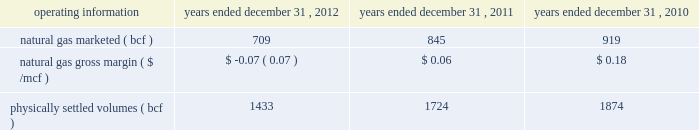Costs .
Our 2012 results were lower than 2011 when we realized $ 53.1 million in premium-services margins and our storage and marketing margins consisted of $ 96.0 million from realized seasonal price differentials and marketing optimization activities , and $ 87.7 million of storage demand costs .
In addition , we recognized a loss on the change in fair value of our nonqualifiying economic storage hedges of $ 1.0 million in 2012 compared with a gain of $ 8.5 million in 2011 .
Our premium services were impacted negatively by lower natural gas prices and decreased natural gas price volatility .
The impact of our hedge strategies and the inability to hedge seasonal price differentials at levels that were available to us in the prior year significantly reduced our storage margins .
We also experienced reduced opportunities to optimize our storage assets , which negatively impacted our marketing margins .
We realized a loss in our transportation margins of $ 42.4 million in 2012 compared with a loss of $ 18.8 million in 2011 , due primarily to a $ 29.5 million decrease in transportation hedges .
Our transportation business continues to be impacted by narrow price location differentials and the inability to hedge at levels that were available to us in prior years .
As a result of significant increases in the supply of natural gas , primarily from shale gas production across north america and new pipeline infrastructure projects , location and seasonal price differentials narrowed significantly beginning in 2010 and continuing through 2012 .
This market change resulted in our transportation contracts being unprofitable impacting our ability to recover our fixed costs .
Operating costs decreased due primarily to lower employee-related expenses , which includes the impact of fewer employees .
We also recognized an expense of $ 10.3 million related to the impairment of our goodwill in the first quarter 2012 .
Given the significant decline in natural gas prices and its effect on location and seasonal price differentials , we performed an interim impairment assessment in the first quarter 2012 that reduced our goodwill balance to zero .
2011 vs .
2010 - the factors discussed in energy services 2019 201cnarrative description of the business 201d included in item i , business , of this annual report have led to a significant decrease in net margin , including : 2022 a decrease of $ 65.3 million in transportation margins , net of hedging , due primarily to narrower location price differentials and lower hedge settlements in 2011 ; 2022 a decrease of $ 34.3 million in storage and marketing margins , net of hedging activities , due primarily to the following : 2013 lower realized seasonal storage price differentials ; offset partially by 2013 favorable marketing activity and unrealized fair value changes on nonqualifying economic storage hedges ; 2022 a decrease of $ 7.3 million in premium-services margins , associated primarily with the reduction in the value of the fees collected for these services as a result of low commodity prices and reduced natural gas price volatility in the first quarter 2011 compared with the first quarter 2010 ; and 2022 a decrease of $ 4.3 million in financial trading margins , as low natural gas prices and reduced natural gas price volatility limited our financial trading opportunities .
Additionally , our 2011 net margin includes $ 91.1 million in adjustments to natural gas inventory reflecting the lower of cost or market value .
Because of the adjustments to our inventory value , we reclassified $ 91.1 million of deferred gains on associated cash flow hedges into earnings .
Operating costs decreased due primarily to a decrease in ad valorem taxes .
Selected operating information - the table sets forth certain selected operating information for our energy services segment for the periods indicated: .
Natural gas volumes marketed and physically settled volumes decreased in 2012 compared with 2011 due primarily to decreased marketing activities , lower transported volumes and reduced transportation capacity .
The decrease in 2011 compared with 2010 was due primarily to lower volumes transported and reduced transportation capacity .
Transportation capacity in certain markets was not utilized due to the economics of the location price differentials as a result of increased supply of natural gas , primarily from shale production , and increased pipeline capacity as a result of new pipeline construction. .
What was the percentage difference in natural gas marketed ( bcf ) between 2010 and 2011? 
Computations: ((845 - 919) / 919)
Answer: -0.08052. 